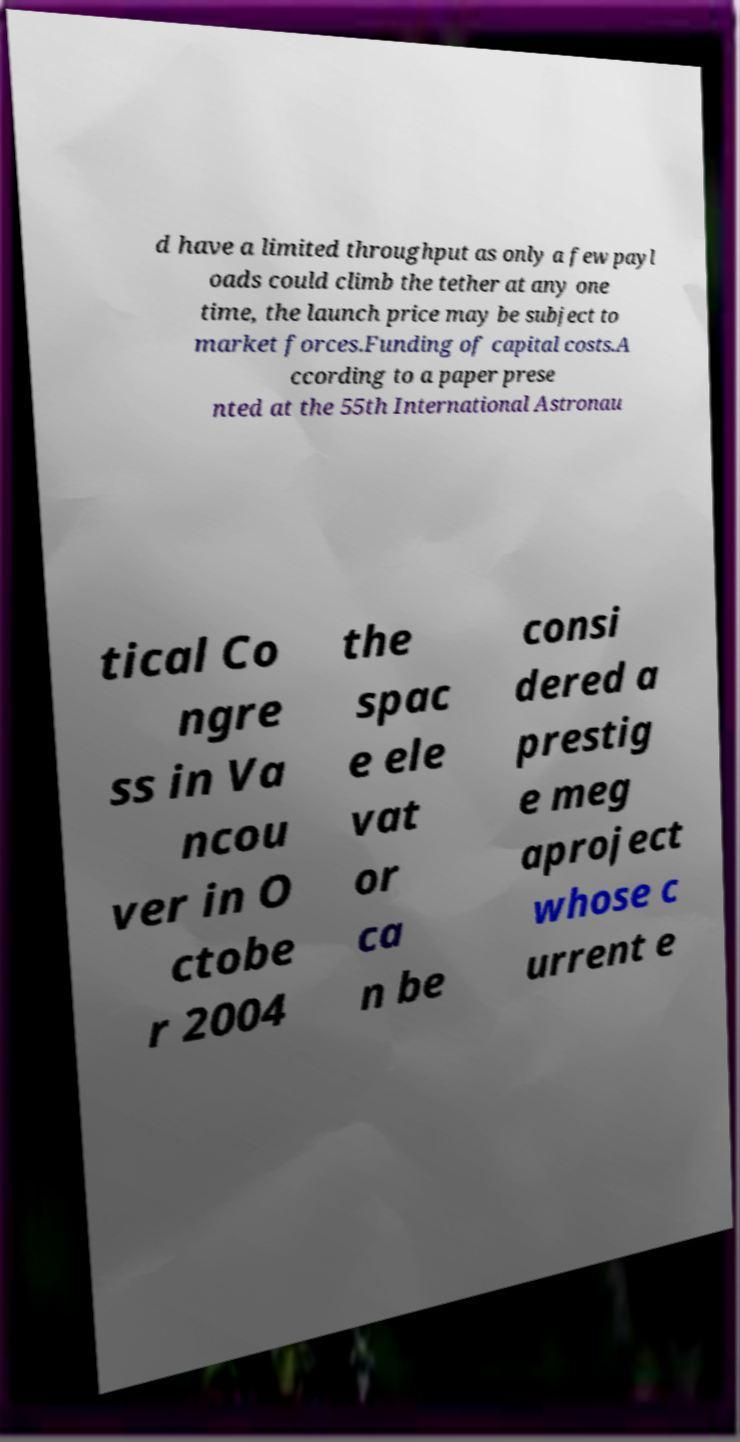There's text embedded in this image that I need extracted. Can you transcribe it verbatim? d have a limited throughput as only a few payl oads could climb the tether at any one time, the launch price may be subject to market forces.Funding of capital costs.A ccording to a paper prese nted at the 55th International Astronau tical Co ngre ss in Va ncou ver in O ctobe r 2004 the spac e ele vat or ca n be consi dered a prestig e meg aproject whose c urrent e 